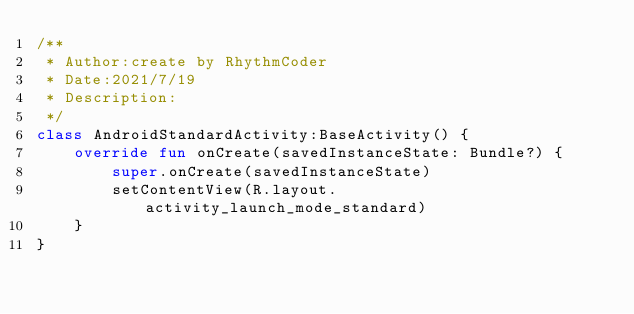<code> <loc_0><loc_0><loc_500><loc_500><_Kotlin_>/**
 * Author:create by RhythmCoder
 * Date:2021/7/19
 * Description:
 */
class AndroidStandardActivity:BaseActivity() {
    override fun onCreate(savedInstanceState: Bundle?) {
        super.onCreate(savedInstanceState)
        setContentView(R.layout.activity_launch_mode_standard)
    }
}</code> 